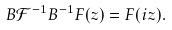Convert formula to latex. <formula><loc_0><loc_0><loc_500><loc_500>B \mathcal { F } ^ { - 1 } B ^ { - 1 } F ( z ) = F ( i z ) .</formula> 